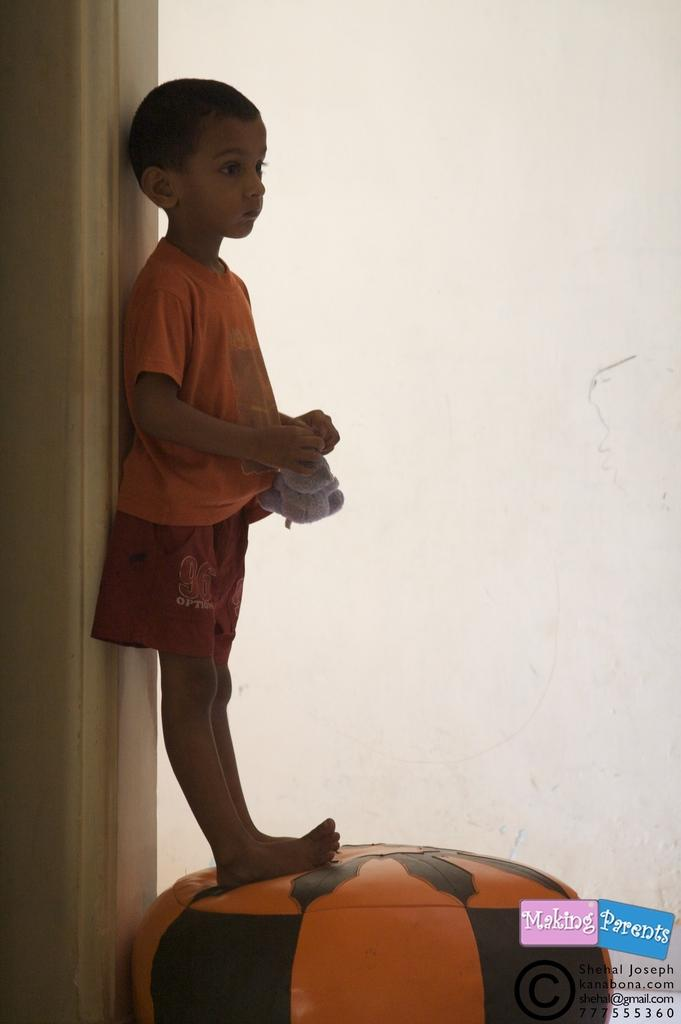Who is the main subject in the image? There is a boy in the image. What is the boy doing in the image? The boy is standing on a cushion. Can you describe the cushion the boy is standing on? The cushion is made of orange and black leather. What can be seen in the background of the image? There is a wall in the background of the image. How many ants are crawling on the boy's knee in the image? There are no ants present in the image, and the boy's knee is not visible. 